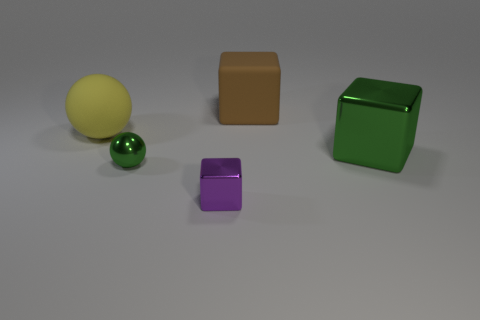What number of other things are the same shape as the yellow matte thing?
Your response must be concise. 1. There is a metallic sphere; is it the same color as the large rubber object left of the tiny metal cube?
Offer a terse response. No. Is there anything else that has the same material as the purple block?
Your answer should be compact. Yes. What is the shape of the purple object in front of the green cube that is to the right of the yellow ball?
Provide a short and direct response. Cube. There is another thing that is the same color as the large shiny object; what size is it?
Make the answer very short. Small. There is a big matte thing left of the tiny metal cube; is its shape the same as the large green metal thing?
Provide a short and direct response. No. Are there more large metallic objects to the left of the large metal object than big yellow rubber objects right of the matte ball?
Provide a short and direct response. No. How many purple things are left of the large thing that is on the right side of the big brown matte block?
Offer a terse response. 1. There is a big thing that is the same color as the shiny ball; what is its material?
Your answer should be very brief. Metal. How many other things are the same color as the tiny cube?
Offer a very short reply. 0. 